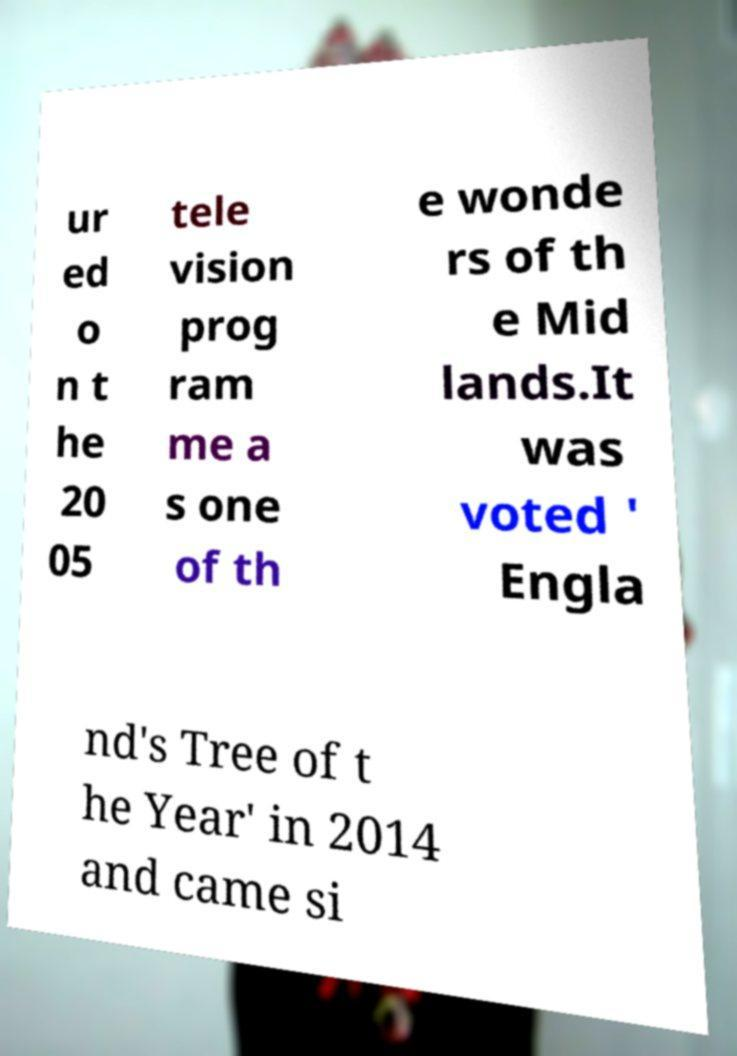Can you read and provide the text displayed in the image?This photo seems to have some interesting text. Can you extract and type it out for me? ur ed o n t he 20 05 tele vision prog ram me a s one of th e wonde rs of th e Mid lands.It was voted ' Engla nd's Tree of t he Year' in 2014 and came si 